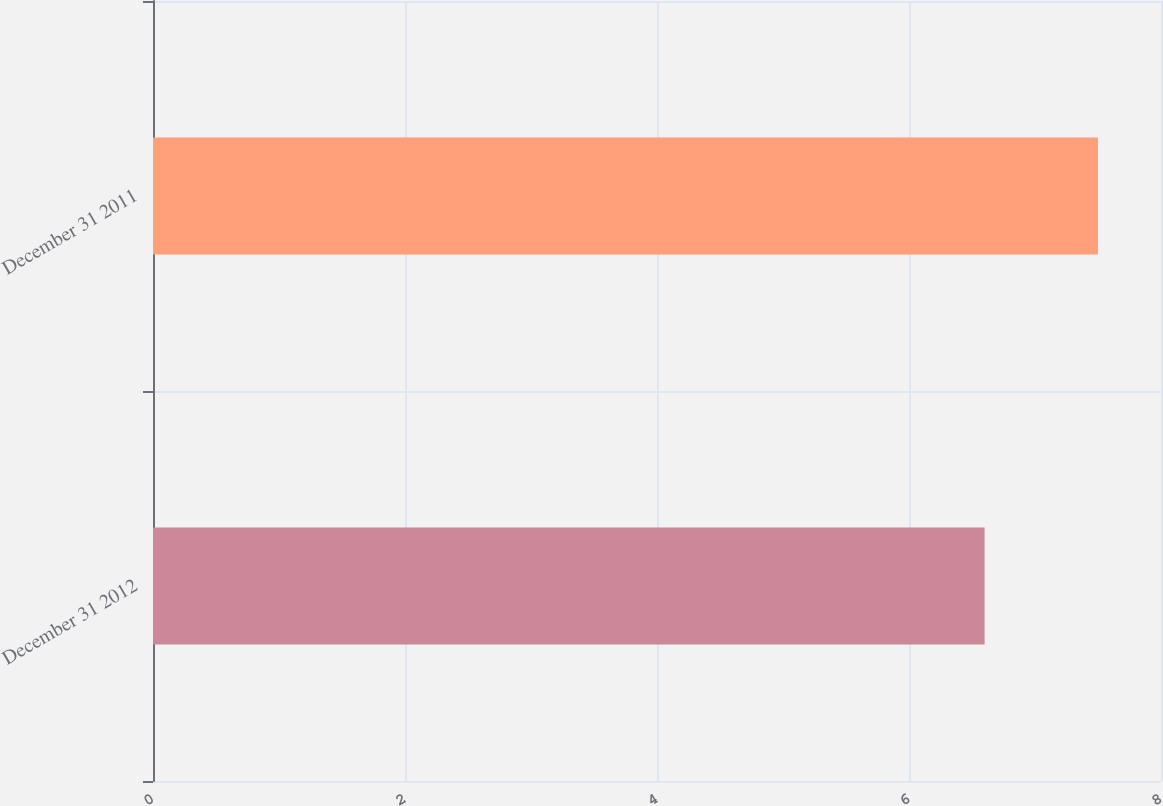<chart> <loc_0><loc_0><loc_500><loc_500><bar_chart><fcel>December 31 2012<fcel>December 31 2011<nl><fcel>6.6<fcel>7.5<nl></chart> 